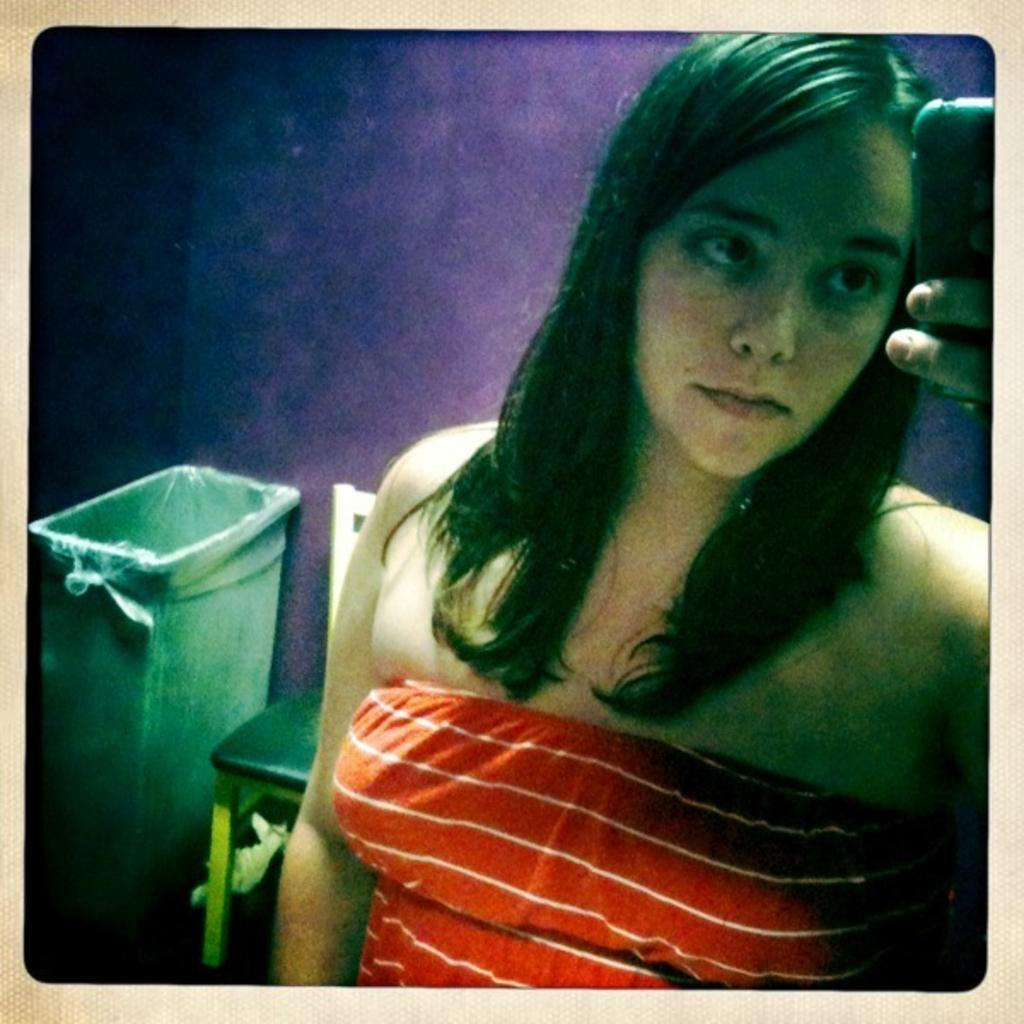What is the main subject of the image? There is a photo in the image. What is the woman in the photo doing? In the photo, a woman is standing. What object is the woman holding in the photo? The woman is holding a mobile phone in the photo. What can be seen behind the woman in the photo? There is a chair visible behind the woman in the photo. What is located behind the chair in the photo? There is a dustbin visible behind the chair in the photo. What is the background of the photo? There is a wall visible behind the dustbin in the photo. Can you tell me how many bubbles are floating around the woman in the photo? There are no bubbles present in the photo; it features a woman holding a mobile phone with a chair, dustbin, and wall visible in the background. 